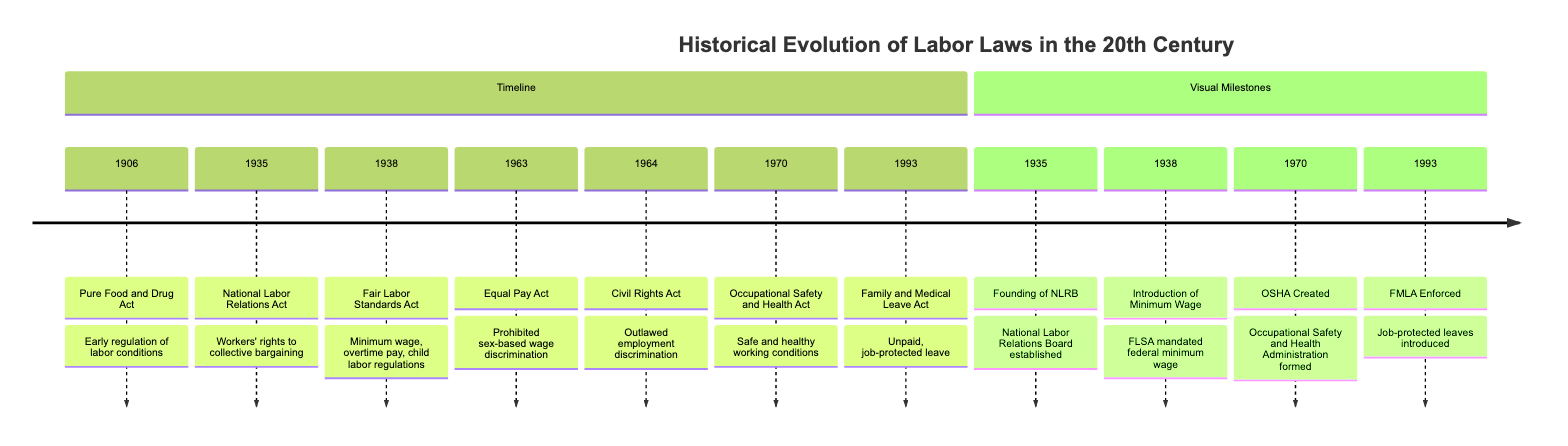What is the year of the Equal Pay Act? The diagram indicates that the Equal Pay Act was enacted in 1963 as shown in the timeline section.
Answer: 1963 What milestone is associated with the year 1970? The visual milestones section indicates that in 1970, the Occupational Safety and Health Administration was created, as noted in the timeline.
Answer: OSHA Created Which law established a federal minimum wage? Referring to the timeline section, the Fair Labor Standards Act in 1938 introduced minimum wage regulations, noted for its significant labor law impact.
Answer: Fair Labor Standards Act How many total laws are mentioned in the timeline? Counting the entries in the timeline section, there are seven notable laws listed from the years 1906 to 1993, each marking an important evolution in labor law.
Answer: 7 What does the National Labor Relations Act support? According to the description in the timeline, the National Labor Relations Act, enacted in 1935, supports workers' rights to collective bargaining, illustrating its primary purpose.
Answer: Collective bargaining Which act came after the Civil Rights Act in 1964? By reviewing the timeline, the next act listed is the Occupational Safety and Health Act from 1970, providing the chronological order following the Civil Rights Act.
Answer: Occupational Safety and Health Act What significant change did the Fair Labor Standards Act bring in 1938? The diagram states that the Fair Labor Standards Act involved child labor regulations, minimum wage, and overtime pay, marking it as a comprehensive labor law overhaul for that time.
Answer: Minimum wage, overtime pay, child labor regulations Which act introduced job-protected leave for family needs? The diagram shows that the Family and Medical Leave Act, enacted in 1993, provided for unpaid, job-protected leave for family and medical reasons, focusing on worker family needs.
Answer: Family and Medical Leave Act 